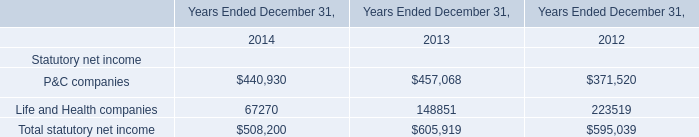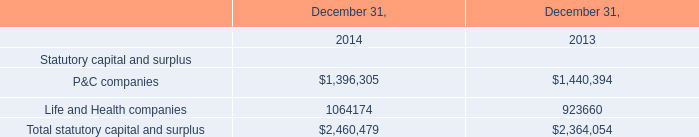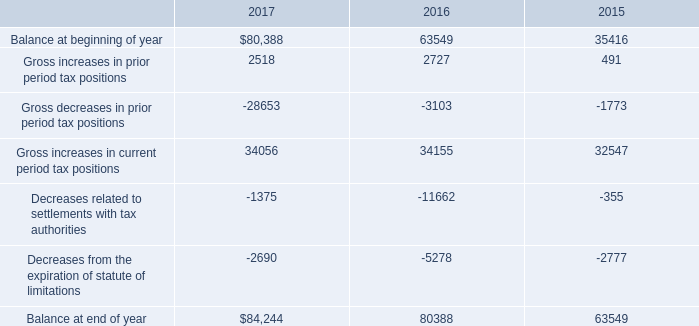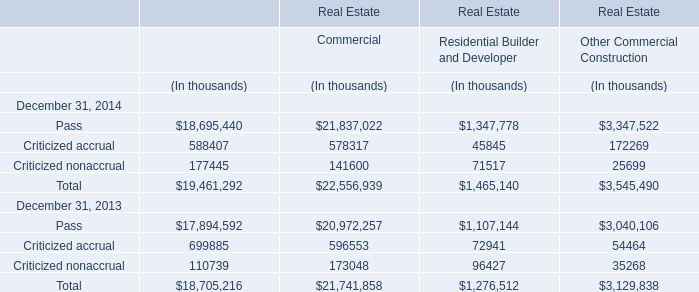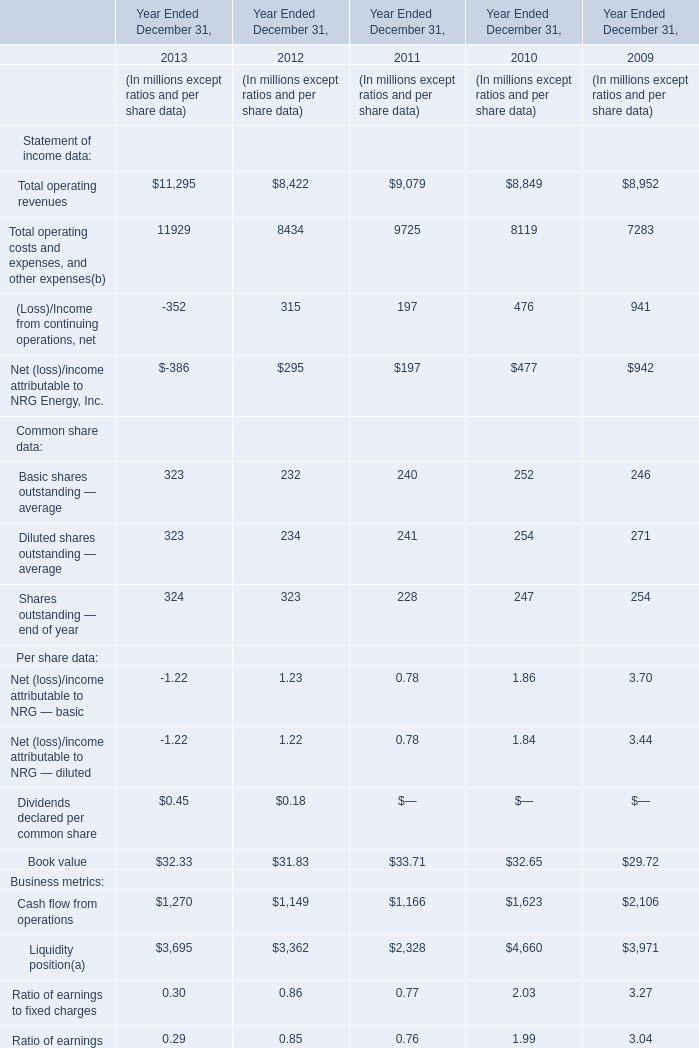What was the total amount of the Book value in the years where Total operating costs and expenses, and other expenses(b greater than 8000? (in million) 
Computations: (((32.33 + 31.83) + 33.71) + 32.65)
Answer: 130.52. 